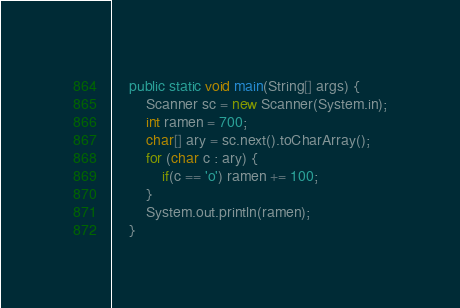<code> <loc_0><loc_0><loc_500><loc_500><_Java_>	public static void main(String[] args) {
		Scanner sc = new Scanner(System.in);
		int ramen = 700;
		char[] ary = sc.next().toCharArray();
		for (char c : ary) {
			if(c == 'o') ramen += 100;
		}
		System.out.println(ramen);
	}</code> 